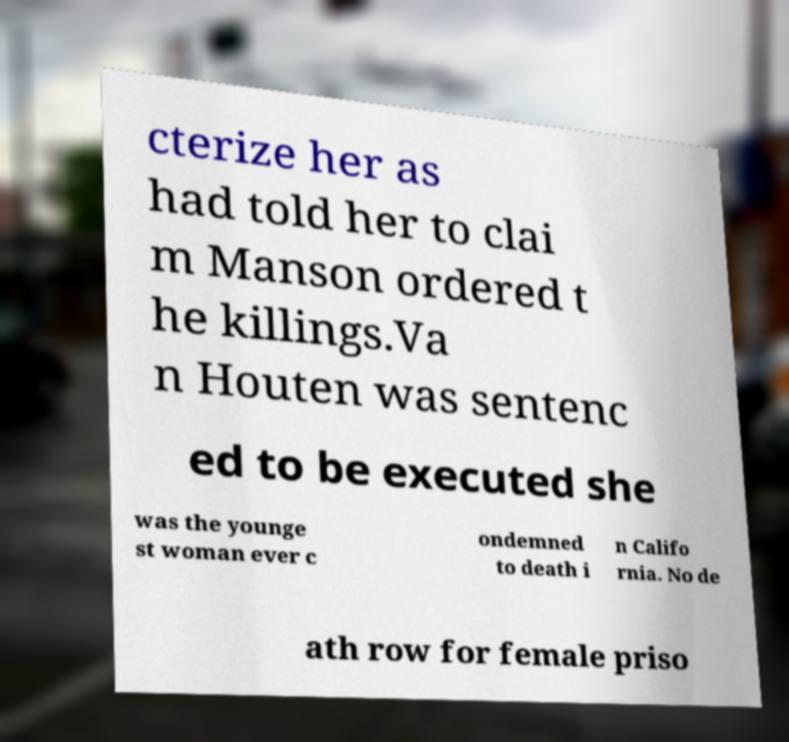Please read and relay the text visible in this image. What does it say? cterize her as had told her to clai m Manson ordered t he killings.Va n Houten was sentenc ed to be executed she was the younge st woman ever c ondemned to death i n Califo rnia. No de ath row for female priso 